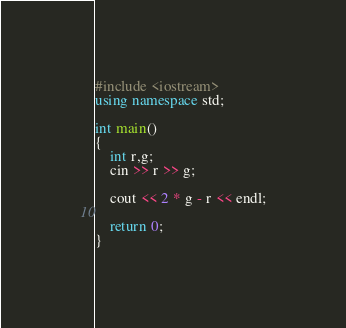Convert code to text. <code><loc_0><loc_0><loc_500><loc_500><_C++_>#include <iostream>
using namespace std;

int main()
{
    int r,g;
    cin >> r >> g;

    cout << 2 * g - r << endl;

    return 0;
}</code> 